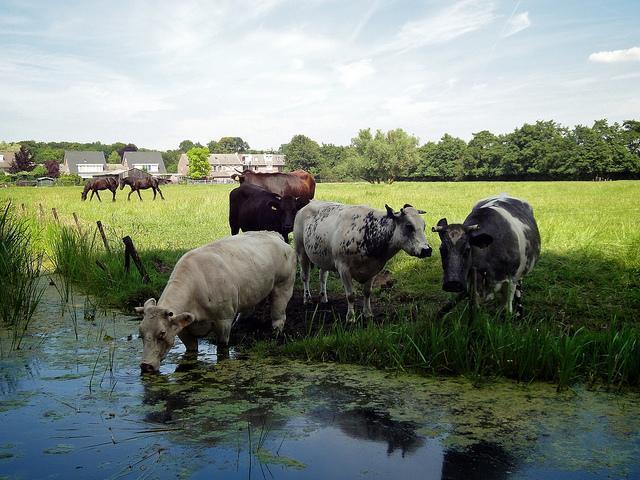Why does the animal have its head to the water?
From the following set of four choices, select the accurate answer to respond to the question.
Options: To spit, to drink, to swim, to dive. To drink. 